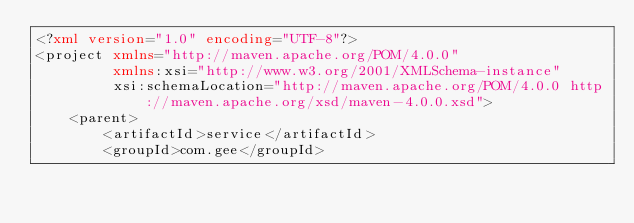<code> <loc_0><loc_0><loc_500><loc_500><_XML_><?xml version="1.0" encoding="UTF-8"?>
<project xmlns="http://maven.apache.org/POM/4.0.0"
         xmlns:xsi="http://www.w3.org/2001/XMLSchema-instance"
         xsi:schemaLocation="http://maven.apache.org/POM/4.0.0 http://maven.apache.org/xsd/maven-4.0.0.xsd">
    <parent>
        <artifactId>service</artifactId>
        <groupId>com.gee</groupId></code> 